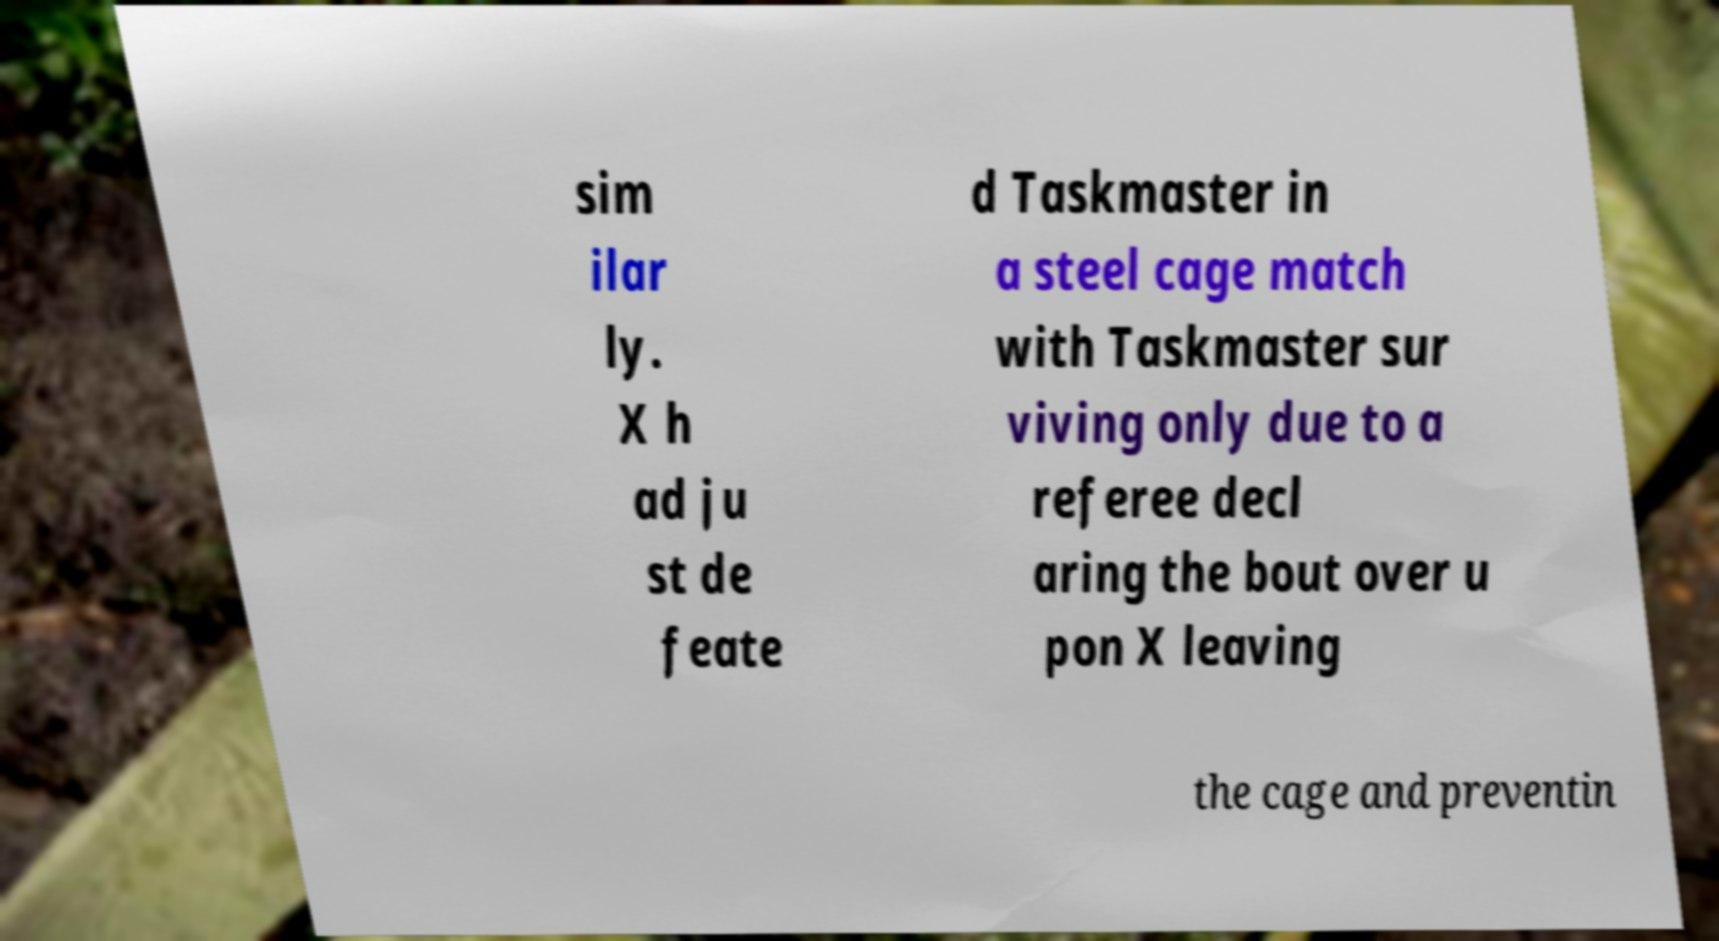Could you assist in decoding the text presented in this image and type it out clearly? sim ilar ly. X h ad ju st de feate d Taskmaster in a steel cage match with Taskmaster sur viving only due to a referee decl aring the bout over u pon X leaving the cage and preventin 